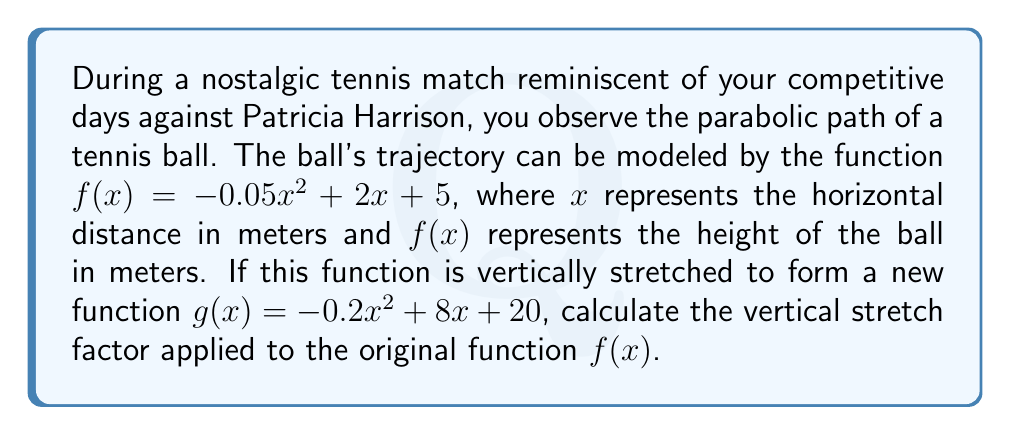Give your solution to this math problem. To find the vertical stretch factor, we need to compare the coefficients of the corresponding terms in the original function $f(x)$ and the new function $g(x)$.

1) The general form of a quadratic function is $f(x) = ax^2 + bx + c$, where $a$, $b$, and $c$ are constants and $a \neq 0$.

2) For the original function $f(x) = -0.05x^2 + 2x + 5$:
   $a_1 = -0.05$, $b_1 = 2$, $c_1 = 5$

3) For the new function $g(x) = -0.2x^2 + 8x + 20$:
   $a_2 = -0.2$, $b_2 = 8$, $c_2 = 20$

4) The vertical stretch factor is the ratio of the new $a$ coefficient to the original $a$ coefficient:

   Stretch factor = $\frac{a_2}{a_1} = \frac{-0.2}{-0.05} = 4$

5) We can verify this by checking the ratios of the other coefficients:
   $\frac{b_2}{b_1} = \frac{8}{2} = 4$
   $\frac{c_2}{c_1} = \frac{20}{5} = 4$

All ratios are consistent, confirming that the vertical stretch factor is 4.
Answer: The vertical stretch factor is 4. 